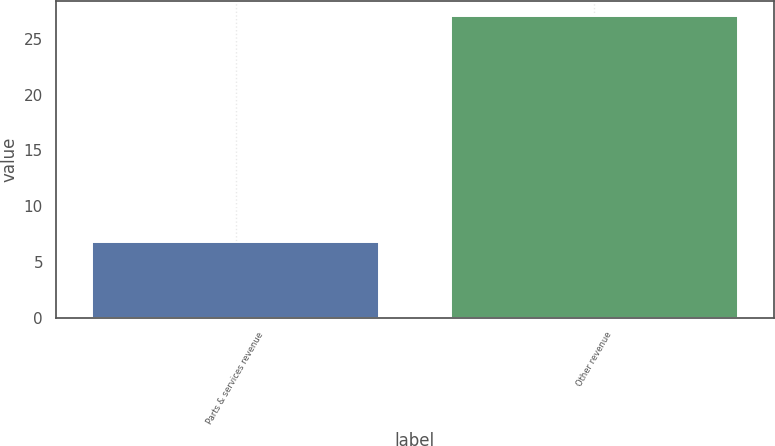Convert chart. <chart><loc_0><loc_0><loc_500><loc_500><bar_chart><fcel>Parts & services revenue<fcel>Other revenue<nl><fcel>6.8<fcel>27.1<nl></chart> 